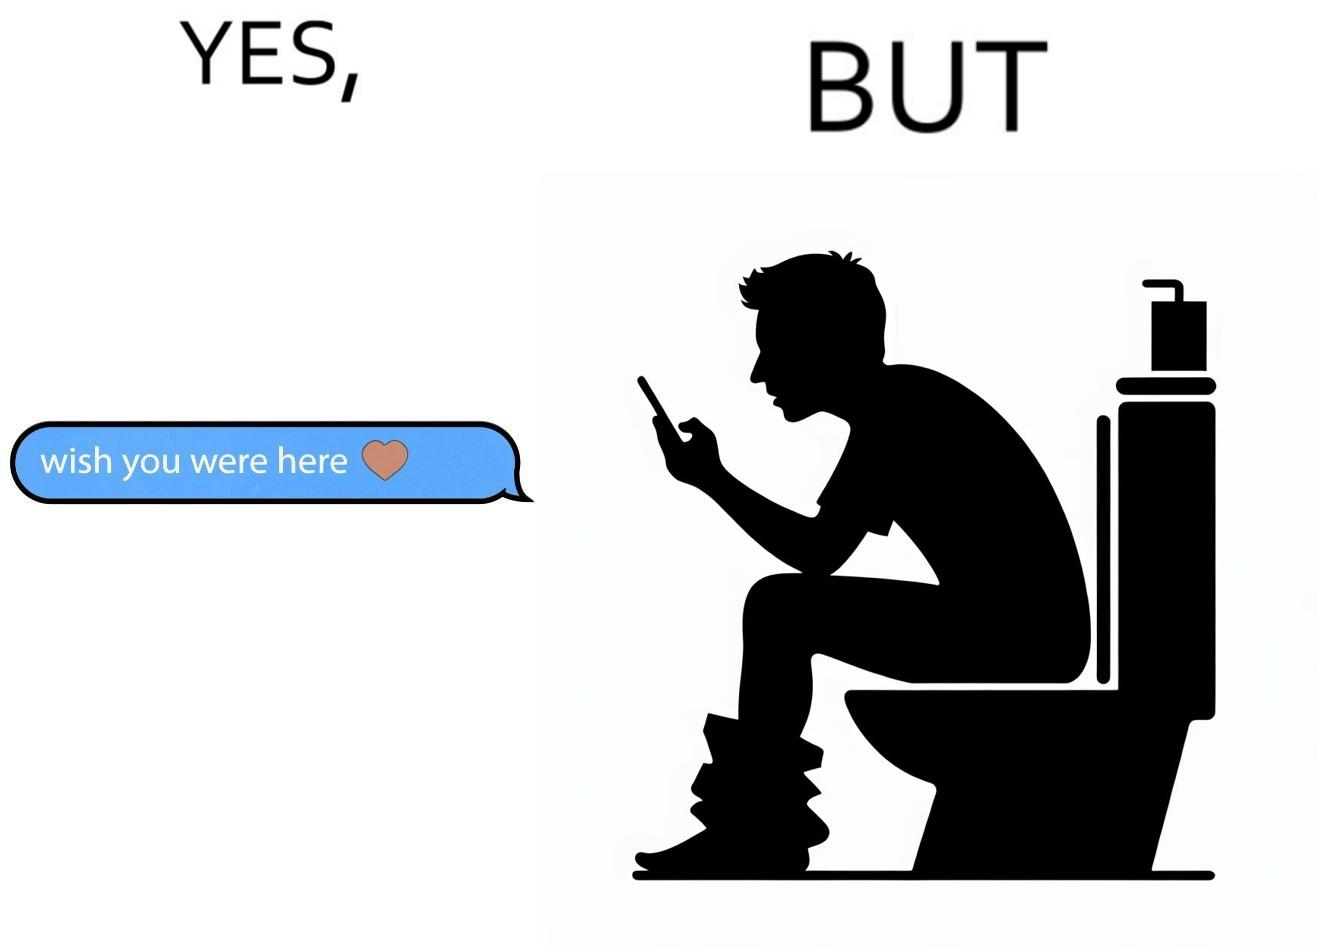Explain the humor or irony in this image. The images are funny since it shows how even though a man writes to his partner that he wishes she was there to show that he misses her, it would be inappropriate and gross if it were to happen literally as he is sitting on his toilet 